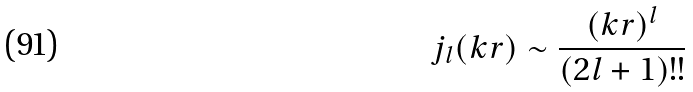<formula> <loc_0><loc_0><loc_500><loc_500>j _ { l } ( k r ) \sim \frac { ( k r ) ^ { l } } { ( 2 l + 1 ) ! ! }</formula> 